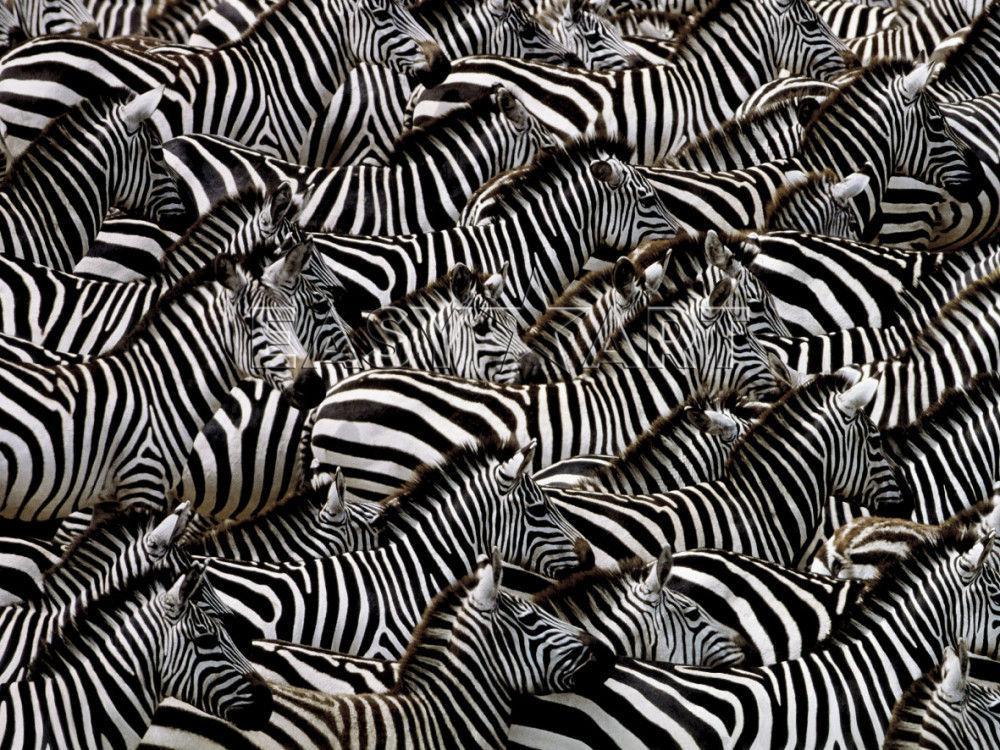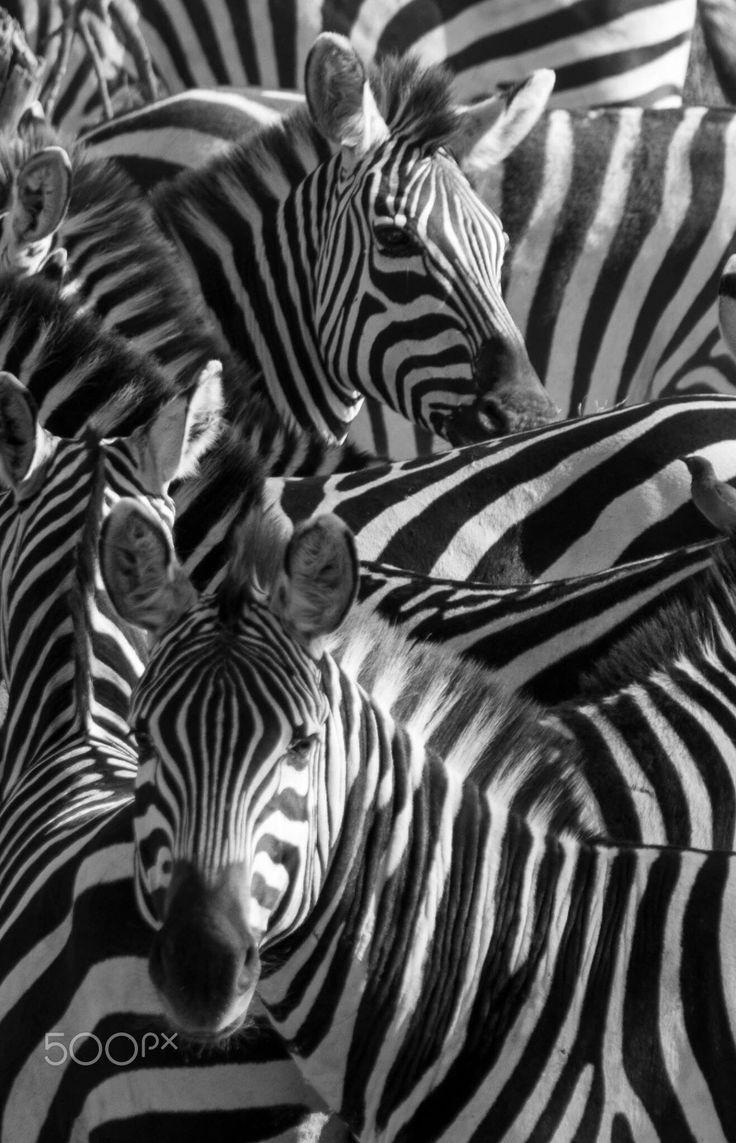The first image is the image on the left, the second image is the image on the right. Examine the images to the left and right. Is the description "At least five zebras are drinking water." accurate? Answer yes or no. No. The first image is the image on the left, the second image is the image on the right. For the images shown, is this caption "In at least one image, zebras are drinking water." true? Answer yes or no. No. 